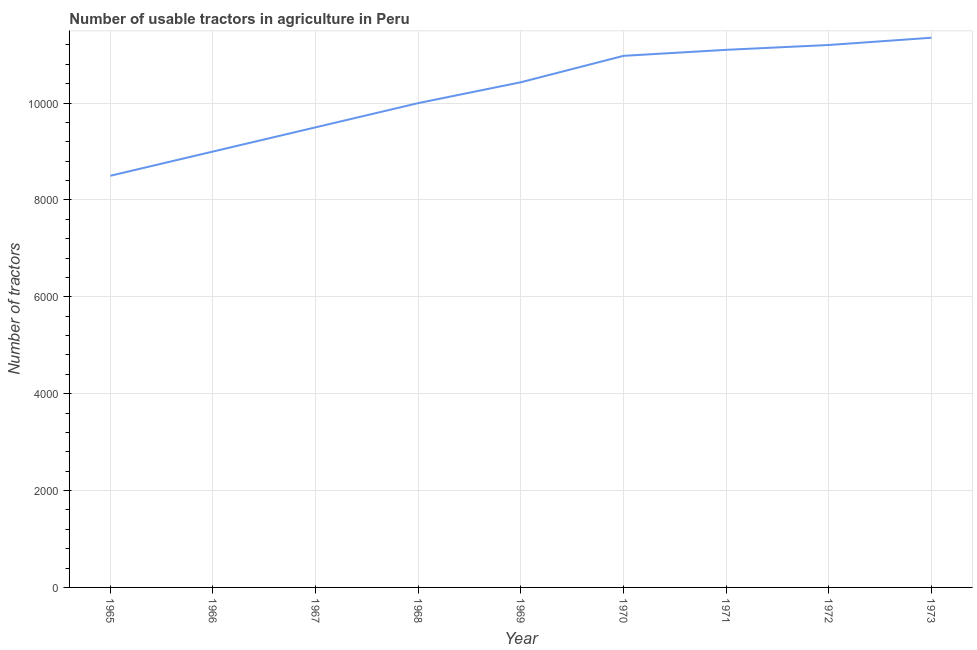What is the number of tractors in 1969?
Your response must be concise. 1.04e+04. Across all years, what is the maximum number of tractors?
Your answer should be very brief. 1.14e+04. Across all years, what is the minimum number of tractors?
Your answer should be very brief. 8500. In which year was the number of tractors maximum?
Your answer should be compact. 1973. In which year was the number of tractors minimum?
Your answer should be very brief. 1965. What is the sum of the number of tractors?
Make the answer very short. 9.21e+04. What is the difference between the number of tractors in 1968 and 1969?
Ensure brevity in your answer.  -431. What is the average number of tractors per year?
Your answer should be very brief. 1.02e+04. What is the median number of tractors?
Your answer should be very brief. 1.04e+04. In how many years, is the number of tractors greater than 3200 ?
Give a very brief answer. 9. Do a majority of the years between 1968 and 1970 (inclusive) have number of tractors greater than 6400 ?
Your answer should be very brief. Yes. Is the number of tractors in 1965 less than that in 1967?
Offer a very short reply. Yes. Is the difference between the number of tractors in 1965 and 1970 greater than the difference between any two years?
Offer a terse response. No. What is the difference between the highest and the second highest number of tractors?
Your answer should be compact. 150. What is the difference between the highest and the lowest number of tractors?
Make the answer very short. 2850. In how many years, is the number of tractors greater than the average number of tractors taken over all years?
Offer a terse response. 5. How many lines are there?
Keep it short and to the point. 1. How many years are there in the graph?
Give a very brief answer. 9. What is the difference between two consecutive major ticks on the Y-axis?
Your answer should be very brief. 2000. Are the values on the major ticks of Y-axis written in scientific E-notation?
Make the answer very short. No. Does the graph contain grids?
Provide a succinct answer. Yes. What is the title of the graph?
Your answer should be very brief. Number of usable tractors in agriculture in Peru. What is the label or title of the Y-axis?
Offer a terse response. Number of tractors. What is the Number of tractors in 1965?
Make the answer very short. 8500. What is the Number of tractors in 1966?
Provide a succinct answer. 9000. What is the Number of tractors in 1967?
Offer a very short reply. 9500. What is the Number of tractors of 1969?
Give a very brief answer. 1.04e+04. What is the Number of tractors of 1970?
Offer a terse response. 1.10e+04. What is the Number of tractors of 1971?
Provide a short and direct response. 1.11e+04. What is the Number of tractors in 1972?
Provide a succinct answer. 1.12e+04. What is the Number of tractors in 1973?
Offer a very short reply. 1.14e+04. What is the difference between the Number of tractors in 1965 and 1966?
Ensure brevity in your answer.  -500. What is the difference between the Number of tractors in 1965 and 1967?
Offer a very short reply. -1000. What is the difference between the Number of tractors in 1965 and 1968?
Your answer should be compact. -1500. What is the difference between the Number of tractors in 1965 and 1969?
Your answer should be very brief. -1931. What is the difference between the Number of tractors in 1965 and 1970?
Ensure brevity in your answer.  -2476. What is the difference between the Number of tractors in 1965 and 1971?
Offer a very short reply. -2600. What is the difference between the Number of tractors in 1965 and 1972?
Your answer should be very brief. -2700. What is the difference between the Number of tractors in 1965 and 1973?
Your answer should be very brief. -2850. What is the difference between the Number of tractors in 1966 and 1967?
Your answer should be very brief. -500. What is the difference between the Number of tractors in 1966 and 1968?
Your answer should be very brief. -1000. What is the difference between the Number of tractors in 1966 and 1969?
Your answer should be compact. -1431. What is the difference between the Number of tractors in 1966 and 1970?
Offer a very short reply. -1976. What is the difference between the Number of tractors in 1966 and 1971?
Offer a very short reply. -2100. What is the difference between the Number of tractors in 1966 and 1972?
Give a very brief answer. -2200. What is the difference between the Number of tractors in 1966 and 1973?
Make the answer very short. -2350. What is the difference between the Number of tractors in 1967 and 1968?
Your response must be concise. -500. What is the difference between the Number of tractors in 1967 and 1969?
Your answer should be very brief. -931. What is the difference between the Number of tractors in 1967 and 1970?
Provide a succinct answer. -1476. What is the difference between the Number of tractors in 1967 and 1971?
Offer a terse response. -1600. What is the difference between the Number of tractors in 1967 and 1972?
Provide a short and direct response. -1700. What is the difference between the Number of tractors in 1967 and 1973?
Make the answer very short. -1850. What is the difference between the Number of tractors in 1968 and 1969?
Your answer should be compact. -431. What is the difference between the Number of tractors in 1968 and 1970?
Your answer should be very brief. -976. What is the difference between the Number of tractors in 1968 and 1971?
Ensure brevity in your answer.  -1100. What is the difference between the Number of tractors in 1968 and 1972?
Give a very brief answer. -1200. What is the difference between the Number of tractors in 1968 and 1973?
Offer a terse response. -1350. What is the difference between the Number of tractors in 1969 and 1970?
Your response must be concise. -545. What is the difference between the Number of tractors in 1969 and 1971?
Keep it short and to the point. -669. What is the difference between the Number of tractors in 1969 and 1972?
Ensure brevity in your answer.  -769. What is the difference between the Number of tractors in 1969 and 1973?
Ensure brevity in your answer.  -919. What is the difference between the Number of tractors in 1970 and 1971?
Your answer should be compact. -124. What is the difference between the Number of tractors in 1970 and 1972?
Offer a terse response. -224. What is the difference between the Number of tractors in 1970 and 1973?
Ensure brevity in your answer.  -374. What is the difference between the Number of tractors in 1971 and 1972?
Provide a succinct answer. -100. What is the difference between the Number of tractors in 1971 and 1973?
Give a very brief answer. -250. What is the difference between the Number of tractors in 1972 and 1973?
Make the answer very short. -150. What is the ratio of the Number of tractors in 1965 to that in 1966?
Make the answer very short. 0.94. What is the ratio of the Number of tractors in 1965 to that in 1967?
Your answer should be very brief. 0.9. What is the ratio of the Number of tractors in 1965 to that in 1969?
Provide a short and direct response. 0.81. What is the ratio of the Number of tractors in 1965 to that in 1970?
Provide a short and direct response. 0.77. What is the ratio of the Number of tractors in 1965 to that in 1971?
Ensure brevity in your answer.  0.77. What is the ratio of the Number of tractors in 1965 to that in 1972?
Ensure brevity in your answer.  0.76. What is the ratio of the Number of tractors in 1965 to that in 1973?
Provide a succinct answer. 0.75. What is the ratio of the Number of tractors in 1966 to that in 1967?
Your answer should be compact. 0.95. What is the ratio of the Number of tractors in 1966 to that in 1969?
Provide a succinct answer. 0.86. What is the ratio of the Number of tractors in 1966 to that in 1970?
Your response must be concise. 0.82. What is the ratio of the Number of tractors in 1966 to that in 1971?
Provide a short and direct response. 0.81. What is the ratio of the Number of tractors in 1966 to that in 1972?
Offer a terse response. 0.8. What is the ratio of the Number of tractors in 1966 to that in 1973?
Make the answer very short. 0.79. What is the ratio of the Number of tractors in 1967 to that in 1968?
Provide a short and direct response. 0.95. What is the ratio of the Number of tractors in 1967 to that in 1969?
Your response must be concise. 0.91. What is the ratio of the Number of tractors in 1967 to that in 1970?
Provide a short and direct response. 0.87. What is the ratio of the Number of tractors in 1967 to that in 1971?
Keep it short and to the point. 0.86. What is the ratio of the Number of tractors in 1967 to that in 1972?
Offer a very short reply. 0.85. What is the ratio of the Number of tractors in 1967 to that in 1973?
Offer a very short reply. 0.84. What is the ratio of the Number of tractors in 1968 to that in 1970?
Provide a succinct answer. 0.91. What is the ratio of the Number of tractors in 1968 to that in 1971?
Your answer should be compact. 0.9. What is the ratio of the Number of tractors in 1968 to that in 1972?
Provide a succinct answer. 0.89. What is the ratio of the Number of tractors in 1968 to that in 1973?
Give a very brief answer. 0.88. What is the ratio of the Number of tractors in 1969 to that in 1972?
Keep it short and to the point. 0.93. What is the ratio of the Number of tractors in 1969 to that in 1973?
Your answer should be very brief. 0.92. What is the ratio of the Number of tractors in 1970 to that in 1972?
Provide a succinct answer. 0.98. What is the ratio of the Number of tractors in 1971 to that in 1972?
Your response must be concise. 0.99. What is the ratio of the Number of tractors in 1971 to that in 1973?
Offer a very short reply. 0.98. What is the ratio of the Number of tractors in 1972 to that in 1973?
Your response must be concise. 0.99. 